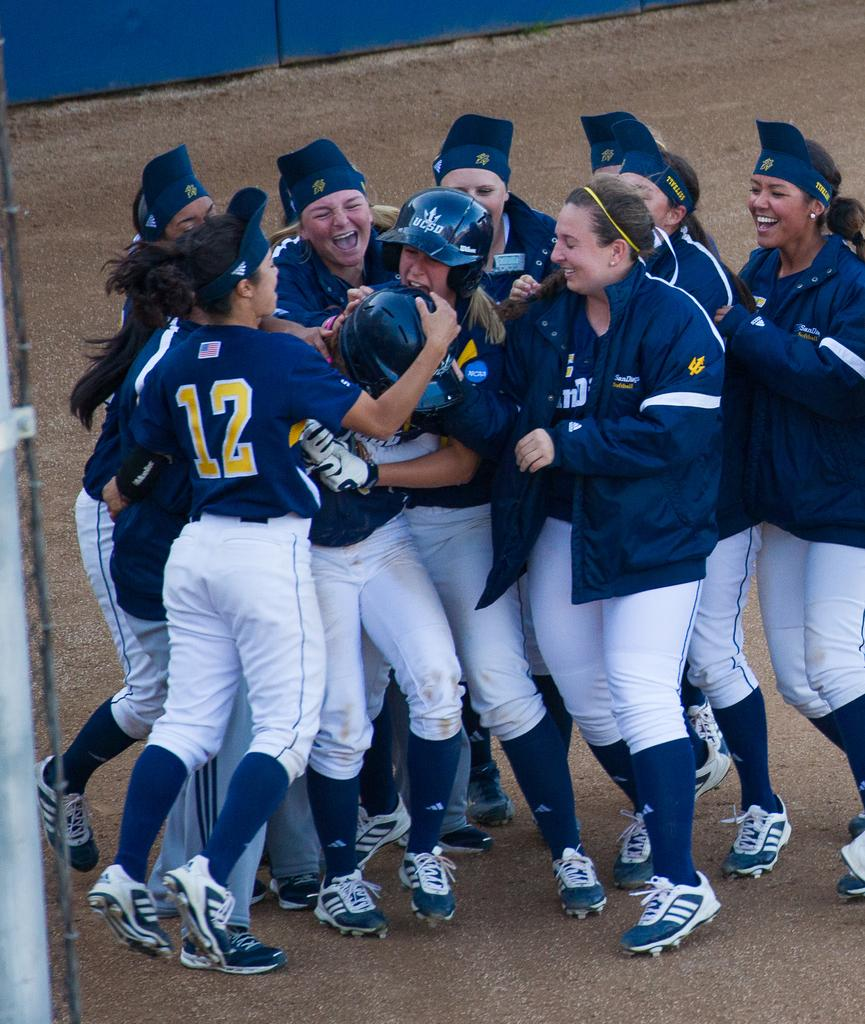Provide a one-sentence caption for the provided image. Baseball players including number 12 hugging one another after a victory. 